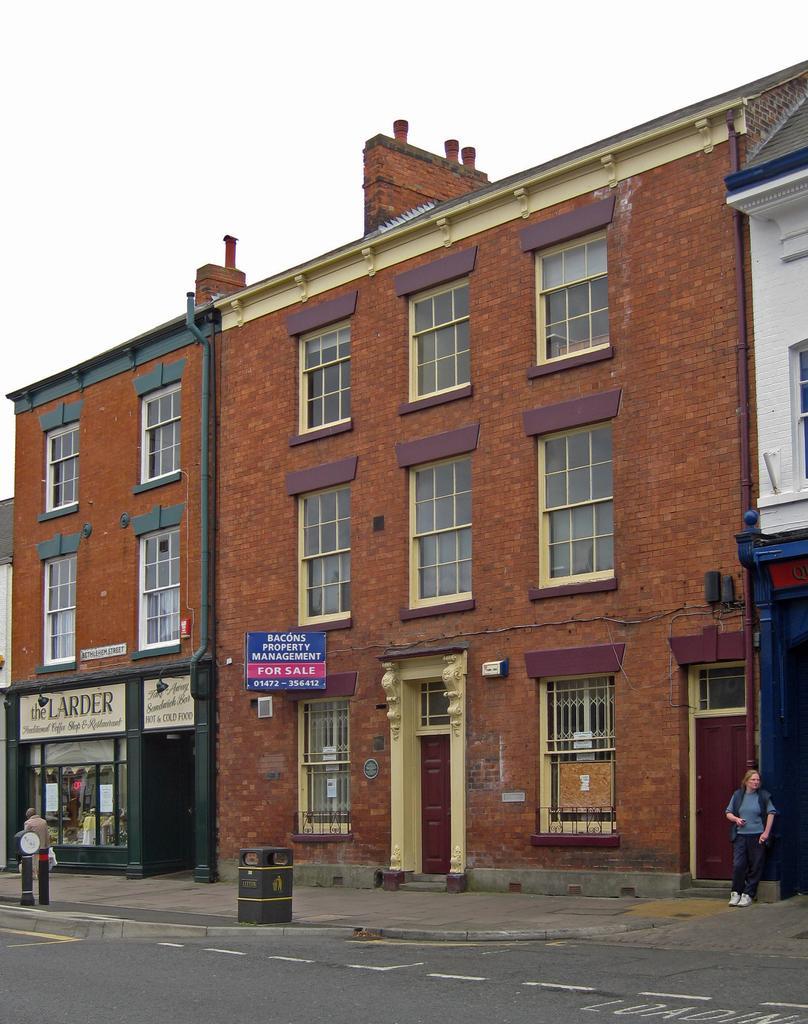Could you give a brief overview of what you see in this image? In the image we can see the building and the windows of the building. There are even people standing and wearing clothes. Here we can see the road, board and text on the board and the sky. 